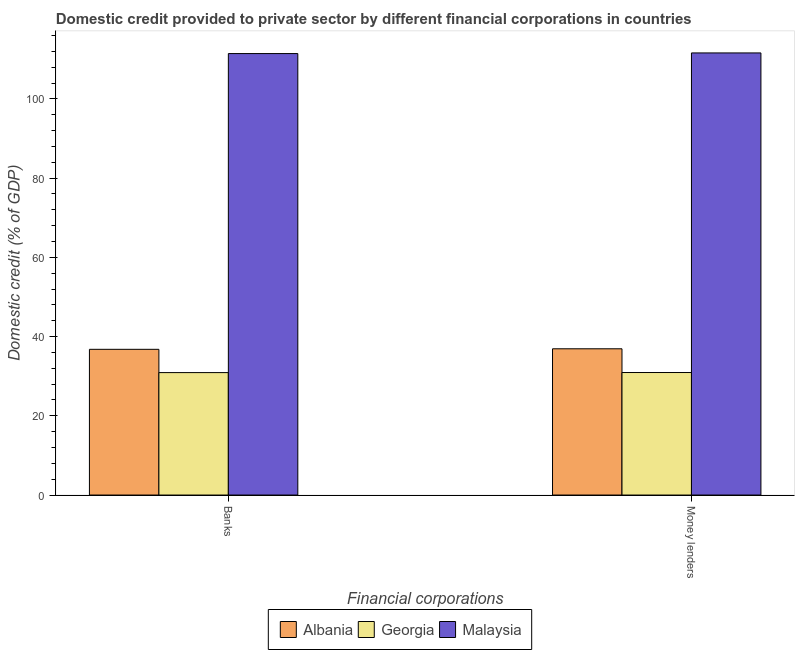How many different coloured bars are there?
Provide a succinct answer. 3. Are the number of bars on each tick of the X-axis equal?
Your answer should be compact. Yes. How many bars are there on the 1st tick from the left?
Provide a short and direct response. 3. How many bars are there on the 2nd tick from the right?
Your answer should be very brief. 3. What is the label of the 1st group of bars from the left?
Your answer should be compact. Banks. What is the domestic credit provided by money lenders in Malaysia?
Your answer should be very brief. 111.61. Across all countries, what is the maximum domestic credit provided by money lenders?
Provide a short and direct response. 111.61. Across all countries, what is the minimum domestic credit provided by money lenders?
Give a very brief answer. 30.93. In which country was the domestic credit provided by banks maximum?
Keep it short and to the point. Malaysia. In which country was the domestic credit provided by money lenders minimum?
Provide a short and direct response. Georgia. What is the total domestic credit provided by money lenders in the graph?
Your response must be concise. 179.45. What is the difference between the domestic credit provided by money lenders in Malaysia and that in Albania?
Give a very brief answer. 74.69. What is the difference between the domestic credit provided by banks in Albania and the domestic credit provided by money lenders in Malaysia?
Offer a very short reply. -74.82. What is the average domestic credit provided by banks per country?
Offer a terse response. 59.71. What is the difference between the domestic credit provided by banks and domestic credit provided by money lenders in Albania?
Your answer should be very brief. -0.13. What is the ratio of the domestic credit provided by banks in Malaysia to that in Albania?
Your answer should be very brief. 3.03. What does the 2nd bar from the left in Banks represents?
Your answer should be compact. Georgia. What does the 2nd bar from the right in Banks represents?
Keep it short and to the point. Georgia. Are all the bars in the graph horizontal?
Your answer should be very brief. No. What is the difference between two consecutive major ticks on the Y-axis?
Give a very brief answer. 20. Does the graph contain any zero values?
Your answer should be compact. No. Where does the legend appear in the graph?
Offer a terse response. Bottom center. What is the title of the graph?
Provide a succinct answer. Domestic credit provided to private sector by different financial corporations in countries. Does "St. Lucia" appear as one of the legend labels in the graph?
Your answer should be compact. No. What is the label or title of the X-axis?
Provide a succinct answer. Financial corporations. What is the label or title of the Y-axis?
Give a very brief answer. Domestic credit (% of GDP). What is the Domestic credit (% of GDP) in Albania in Banks?
Provide a succinct answer. 36.78. What is the Domestic credit (% of GDP) of Georgia in Banks?
Provide a short and direct response. 30.91. What is the Domestic credit (% of GDP) in Malaysia in Banks?
Provide a succinct answer. 111.45. What is the Domestic credit (% of GDP) of Albania in Money lenders?
Provide a short and direct response. 36.92. What is the Domestic credit (% of GDP) in Georgia in Money lenders?
Provide a short and direct response. 30.93. What is the Domestic credit (% of GDP) of Malaysia in Money lenders?
Offer a terse response. 111.61. Across all Financial corporations, what is the maximum Domestic credit (% of GDP) in Albania?
Your response must be concise. 36.92. Across all Financial corporations, what is the maximum Domestic credit (% of GDP) in Georgia?
Offer a terse response. 30.93. Across all Financial corporations, what is the maximum Domestic credit (% of GDP) of Malaysia?
Your answer should be compact. 111.61. Across all Financial corporations, what is the minimum Domestic credit (% of GDP) in Albania?
Provide a short and direct response. 36.78. Across all Financial corporations, what is the minimum Domestic credit (% of GDP) in Georgia?
Your answer should be compact. 30.91. Across all Financial corporations, what is the minimum Domestic credit (% of GDP) in Malaysia?
Your response must be concise. 111.45. What is the total Domestic credit (% of GDP) of Albania in the graph?
Make the answer very short. 73.7. What is the total Domestic credit (% of GDP) in Georgia in the graph?
Your answer should be very brief. 61.83. What is the total Domestic credit (% of GDP) in Malaysia in the graph?
Give a very brief answer. 223.05. What is the difference between the Domestic credit (% of GDP) in Albania in Banks and that in Money lenders?
Ensure brevity in your answer.  -0.13. What is the difference between the Domestic credit (% of GDP) in Georgia in Banks and that in Money lenders?
Give a very brief answer. -0.02. What is the difference between the Domestic credit (% of GDP) of Malaysia in Banks and that in Money lenders?
Keep it short and to the point. -0.16. What is the difference between the Domestic credit (% of GDP) in Albania in Banks and the Domestic credit (% of GDP) in Georgia in Money lenders?
Your answer should be compact. 5.86. What is the difference between the Domestic credit (% of GDP) of Albania in Banks and the Domestic credit (% of GDP) of Malaysia in Money lenders?
Keep it short and to the point. -74.82. What is the difference between the Domestic credit (% of GDP) of Georgia in Banks and the Domestic credit (% of GDP) of Malaysia in Money lenders?
Provide a short and direct response. -80.7. What is the average Domestic credit (% of GDP) in Albania per Financial corporations?
Make the answer very short. 36.85. What is the average Domestic credit (% of GDP) of Georgia per Financial corporations?
Ensure brevity in your answer.  30.92. What is the average Domestic credit (% of GDP) in Malaysia per Financial corporations?
Give a very brief answer. 111.53. What is the difference between the Domestic credit (% of GDP) in Albania and Domestic credit (% of GDP) in Georgia in Banks?
Your response must be concise. 5.88. What is the difference between the Domestic credit (% of GDP) of Albania and Domestic credit (% of GDP) of Malaysia in Banks?
Your answer should be very brief. -74.66. What is the difference between the Domestic credit (% of GDP) in Georgia and Domestic credit (% of GDP) in Malaysia in Banks?
Provide a succinct answer. -80.54. What is the difference between the Domestic credit (% of GDP) in Albania and Domestic credit (% of GDP) in Georgia in Money lenders?
Make the answer very short. 5.99. What is the difference between the Domestic credit (% of GDP) in Albania and Domestic credit (% of GDP) in Malaysia in Money lenders?
Your answer should be very brief. -74.69. What is the difference between the Domestic credit (% of GDP) in Georgia and Domestic credit (% of GDP) in Malaysia in Money lenders?
Ensure brevity in your answer.  -80.68. What is the ratio of the Domestic credit (% of GDP) of Malaysia in Banks to that in Money lenders?
Your response must be concise. 1. What is the difference between the highest and the second highest Domestic credit (% of GDP) of Albania?
Your response must be concise. 0.13. What is the difference between the highest and the second highest Domestic credit (% of GDP) of Georgia?
Your answer should be very brief. 0.02. What is the difference between the highest and the second highest Domestic credit (% of GDP) of Malaysia?
Offer a terse response. 0.16. What is the difference between the highest and the lowest Domestic credit (% of GDP) of Albania?
Your response must be concise. 0.13. What is the difference between the highest and the lowest Domestic credit (% of GDP) of Georgia?
Your response must be concise. 0.02. What is the difference between the highest and the lowest Domestic credit (% of GDP) in Malaysia?
Ensure brevity in your answer.  0.16. 